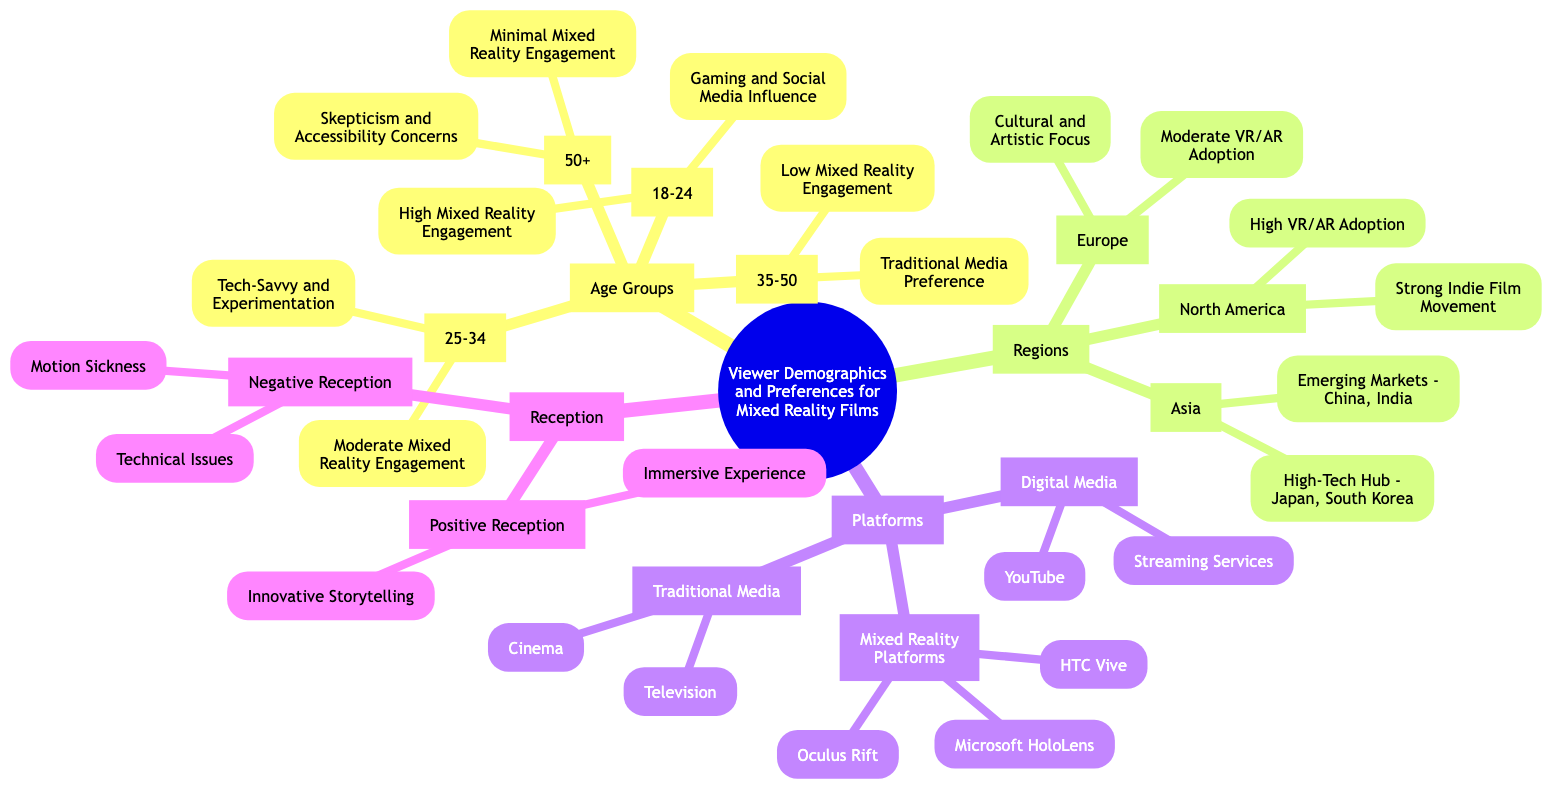What age group shows the highest mixed reality engagement? The diagram indicates that the age group 18-24 demonstrates "High Mixed Reality Engagement." This is derived directly from the "Age Groups" section, specifically under the "18-24" node.
Answer: 18-24 Which region has a strong indie film movement? In the "Regions" section, North America is specifically noted for having a "Strong Indie Film Movement." This can be found under the North America node.
Answer: North America What platform does not include mixed reality technology? The "Traditional Media" category under "Platforms" lists Television and Cinema, neither of which incorporates mixed reality technology. This is evident as the node specifically addresses formats of traditional media.
Answer: Traditional Media How does the 35-50 age group prefer to consume media? According to the "35-50" node under "Age Groups," this demographic shows a "Traditional Media Preference." This means they tend to favor traditional forms of media.
Answer: Traditional Media Preference What are the two main reasons for negative reception of mixed reality content? The "Negative Reception" section lists "Technical Issues" and "Motion Sickness" as the two primary reasons for negative feedback. This indicates common challenges faced by users.
Answer: Technical Issues, Motion Sickness Which platform is associated with high VR/AR adoption? Under the "Regions" section, North America is stated to have "High VR/AR Adoption." This refers to the platforms and technologies embraced in that geographical area.
Answer: North America What is the indicative reception of immersive experience in mixed reality? The diagram states that under "Positive Reception," "Immersive Experience" is highlighted as a key positive aspect. This signifies the audience's appreciation for the engaging nature of the content.
Answer: Immersive Experience Which age group is characterized by minimal mixed reality engagement? The "50+" age group reflects "Minimal Mixed Reality Engagement." This information is found in the "Age Groups" section under the 50+ node, illustrating their lower interaction with this content type.
Answer: 50+ What characterizes the audience preferences in Asia for mixed reality? The "Asia" node indicates it as a "High-Tech Hub," specifically mentioning Japan and South Korea, while also recognizing "Emerging Markets" like China and India, showing diverse audience preferences.
Answer: High-Tech Hub, Emerging Markets 